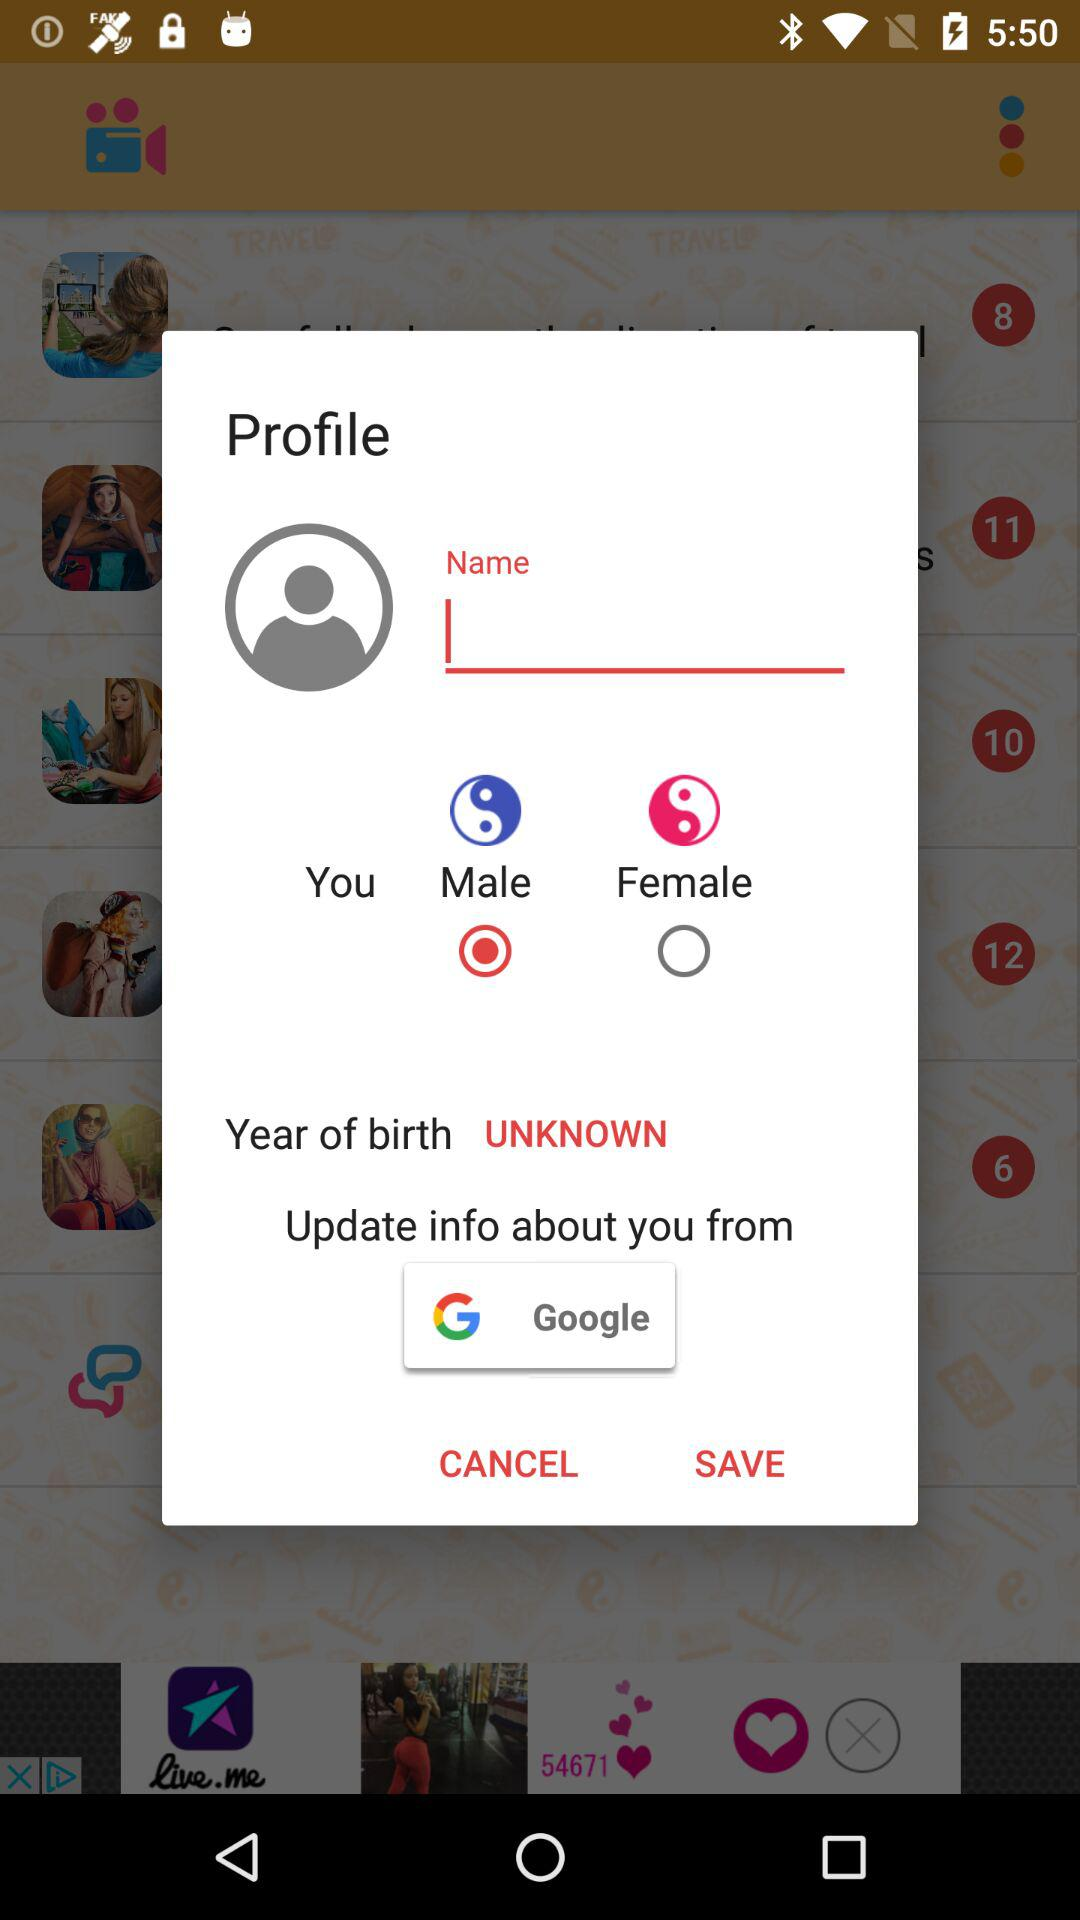What is the selected gender? The selected gender is male. 